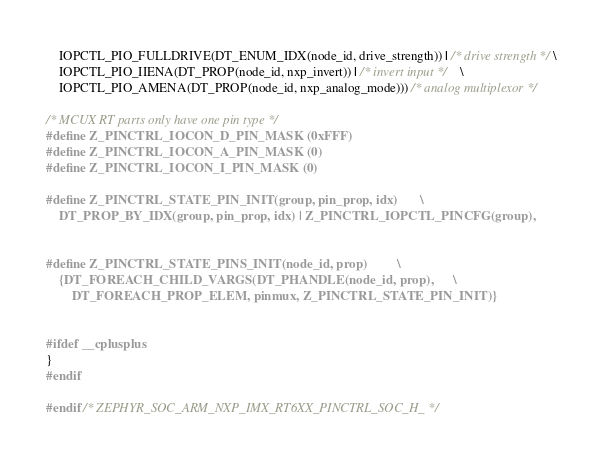Convert code to text. <code><loc_0><loc_0><loc_500><loc_500><_C_>	IOPCTL_PIO_FULLDRIVE(DT_ENUM_IDX(node_id, drive_strength)) | /* drive strength */ \
	IOPCTL_PIO_IIENA(DT_PROP(node_id, nxp_invert)) | /* invert input */	\
	IOPCTL_PIO_AMENA(DT_PROP(node_id, nxp_analog_mode))) /* analog multiplexor */

/* MCUX RT parts only have one pin type */
#define Z_PINCTRL_IOCON_D_PIN_MASK (0xFFF)
#define Z_PINCTRL_IOCON_A_PIN_MASK (0)
#define Z_PINCTRL_IOCON_I_PIN_MASK (0)

#define Z_PINCTRL_STATE_PIN_INIT(group, pin_prop, idx)		\
	DT_PROP_BY_IDX(group, pin_prop, idx) | Z_PINCTRL_IOPCTL_PINCFG(group),


#define Z_PINCTRL_STATE_PINS_INIT(node_id, prop)			\
	{DT_FOREACH_CHILD_VARGS(DT_PHANDLE(node_id, prop),		\
		DT_FOREACH_PROP_ELEM, pinmux, Z_PINCTRL_STATE_PIN_INIT)}


#ifdef __cplusplus
}
#endif

#endif /* ZEPHYR_SOC_ARM_NXP_IMX_RT6XX_PINCTRL_SOC_H_ */
</code> 